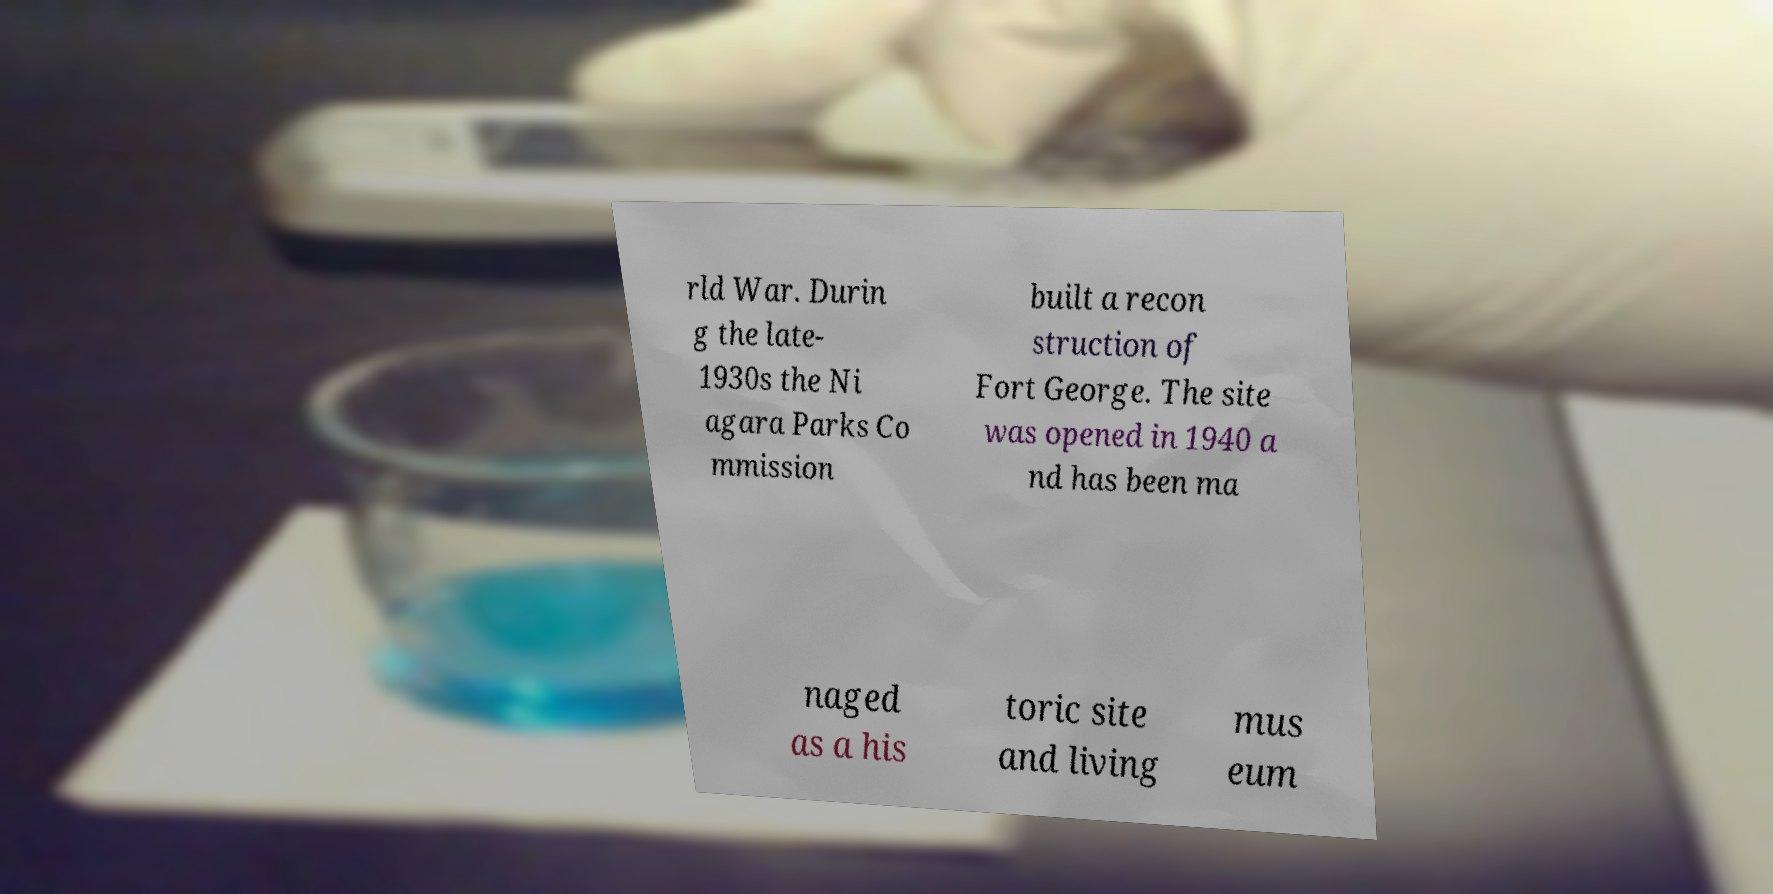Please identify and transcribe the text found in this image. rld War. Durin g the late- 1930s the Ni agara Parks Co mmission built a recon struction of Fort George. The site was opened in 1940 a nd has been ma naged as a his toric site and living mus eum 